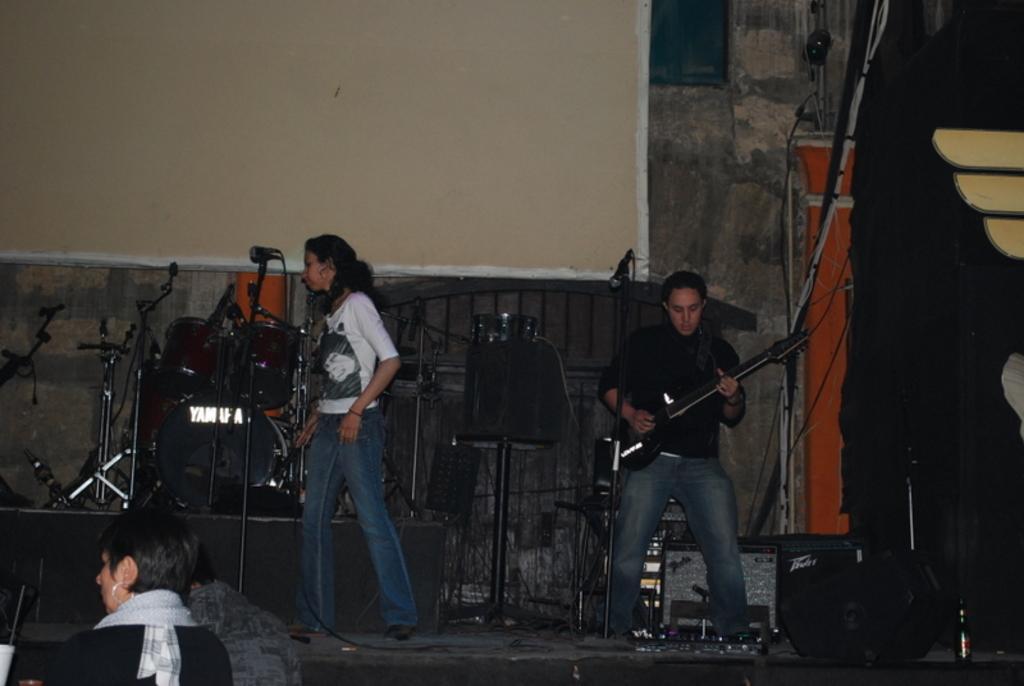Describe this image in one or two sentences. In the middle of the image a woman is standing. Bottom right side of the image a man is holding and playing guitar. Bottom left side of the image few people are there. In the middle of the image there are some musical instruments. At the top of the image there is a wall. 